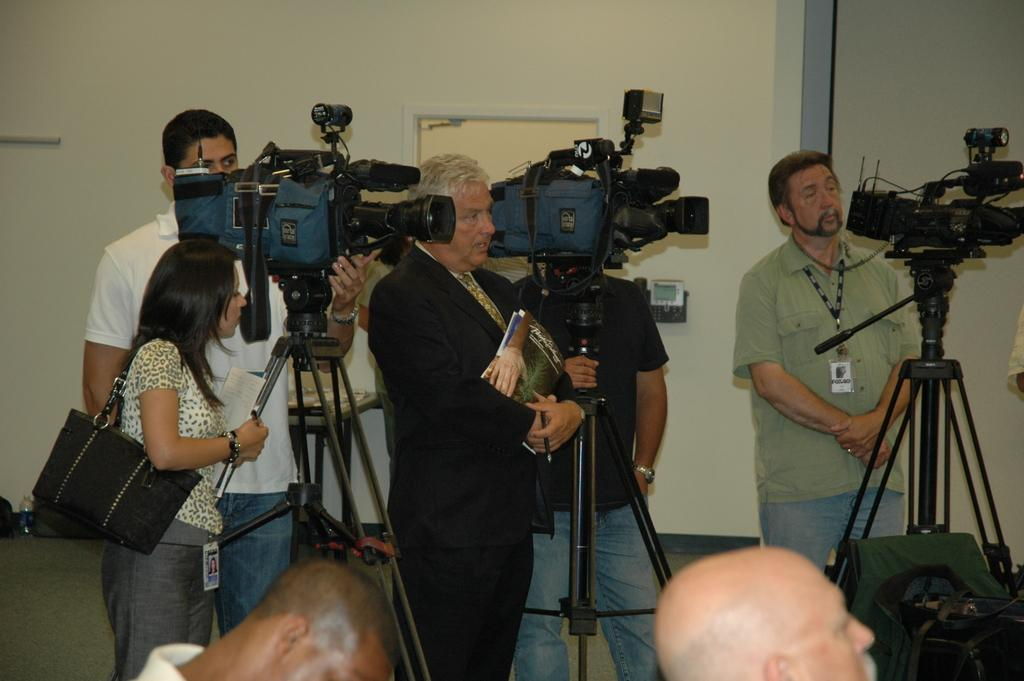What are the people in the image doing? The people in the image are standing. What objects are some of the people holding? Some people are holding cameras, and one person is holding books. What architectural features can be seen in the image? There is a door and a wall visible in the image. What type of jeans is the person wearing in the image? There is no information about jeans in the image, as the focus is on the people standing and the objects they are holding. 